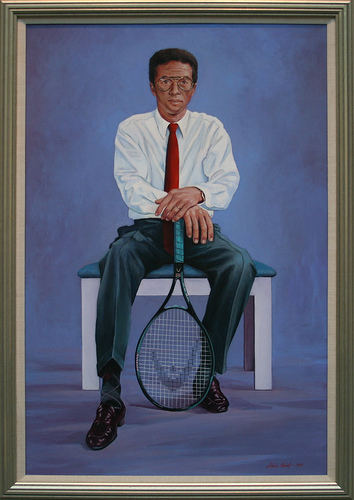Please provide the bounding box coordinate of the region this sentence describes: tennis racket standing on head. The tennis racket standing on its head is located approximately within coordinates [0.4, 0.4, 0.58, 0.83]. 